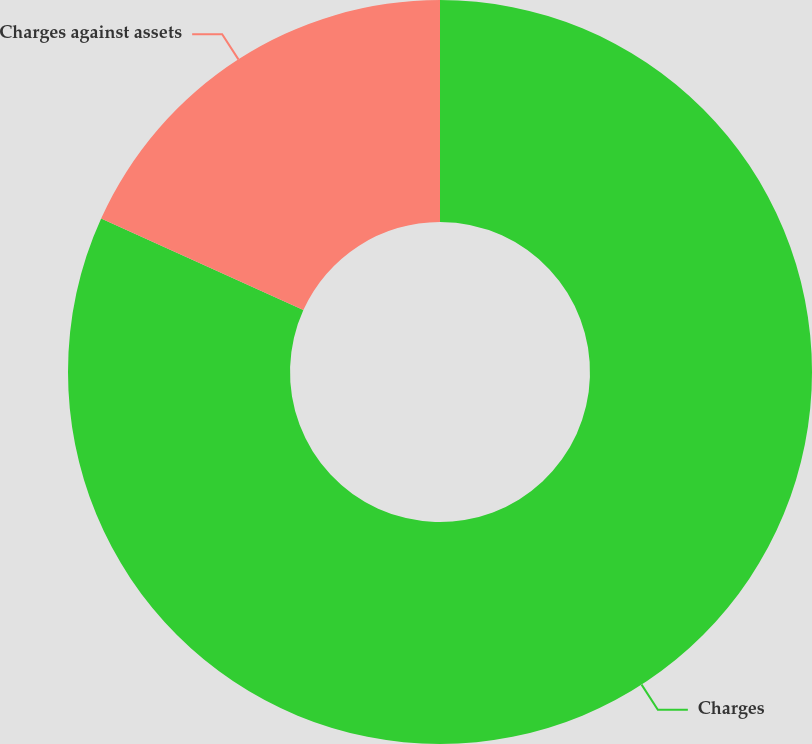Convert chart. <chart><loc_0><loc_0><loc_500><loc_500><pie_chart><fcel>Charges<fcel>Charges against assets<nl><fcel>81.77%<fcel>18.23%<nl></chart> 